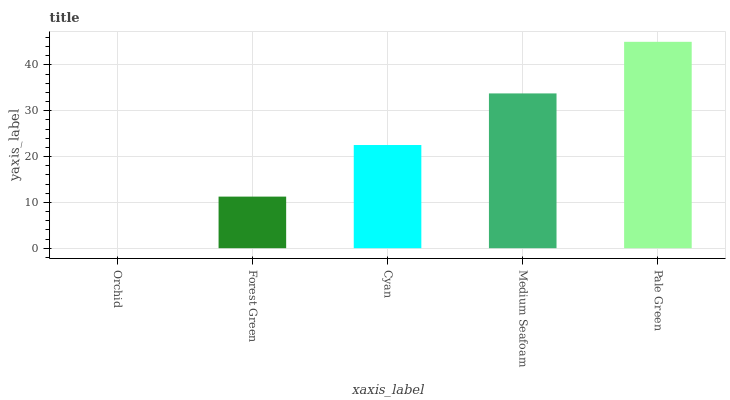Is Orchid the minimum?
Answer yes or no. Yes. Is Pale Green the maximum?
Answer yes or no. Yes. Is Forest Green the minimum?
Answer yes or no. No. Is Forest Green the maximum?
Answer yes or no. No. Is Forest Green greater than Orchid?
Answer yes or no. Yes. Is Orchid less than Forest Green?
Answer yes or no. Yes. Is Orchid greater than Forest Green?
Answer yes or no. No. Is Forest Green less than Orchid?
Answer yes or no. No. Is Cyan the high median?
Answer yes or no. Yes. Is Cyan the low median?
Answer yes or no. Yes. Is Pale Green the high median?
Answer yes or no. No. Is Pale Green the low median?
Answer yes or no. No. 